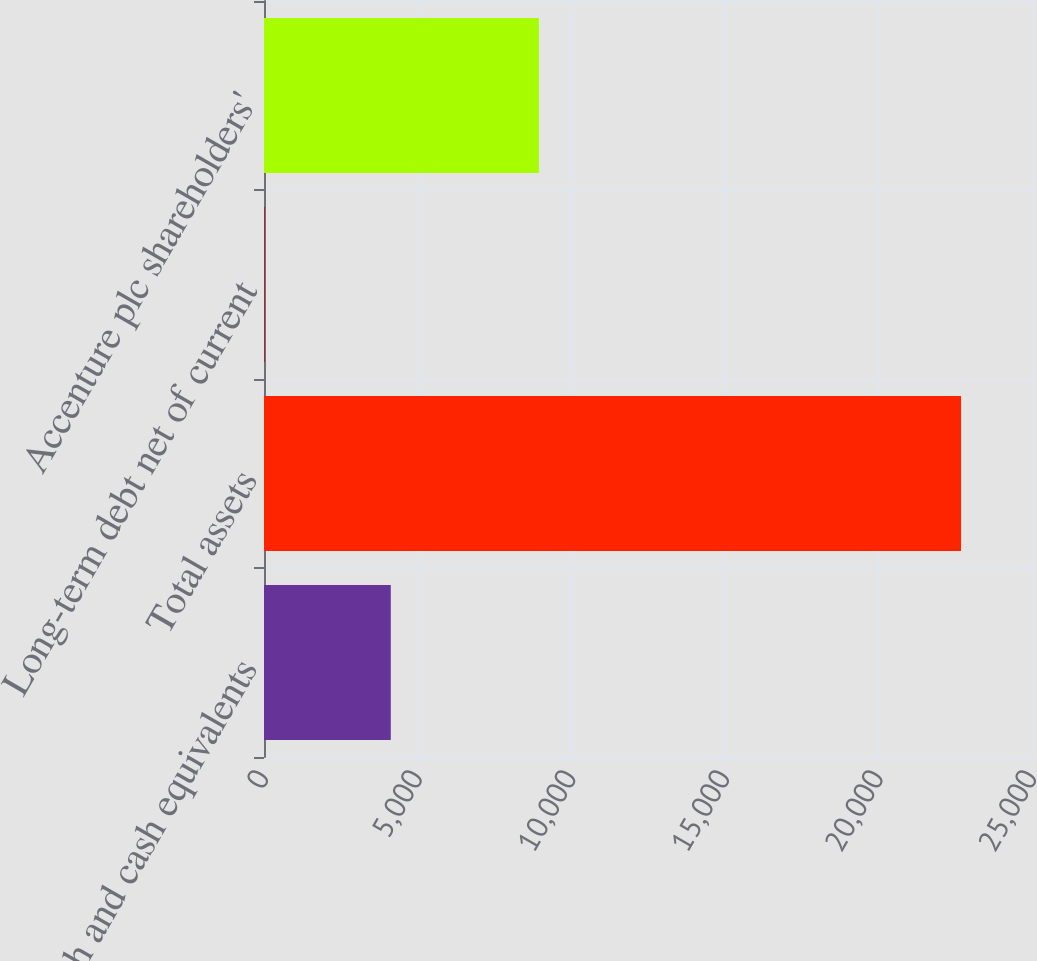Convert chart to OTSL. <chart><loc_0><loc_0><loc_500><loc_500><bar_chart><fcel>Cash and cash equivalents<fcel>Total assets<fcel>Long-term debt net of current<fcel>Accenture plc shareholders'<nl><fcel>4127<fcel>22690<fcel>22<fcel>8949<nl></chart> 